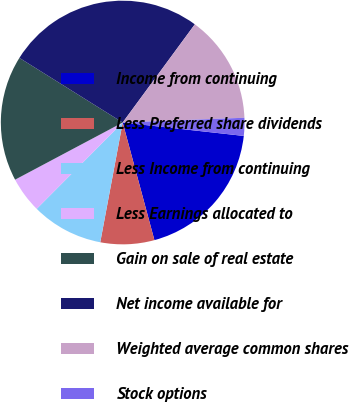Convert chart. <chart><loc_0><loc_0><loc_500><loc_500><pie_chart><fcel>Income from continuing<fcel>Less Preferred share dividends<fcel>Less Income from continuing<fcel>Less Earnings allocated to<fcel>Gain on sale of real estate<fcel>Net income available for<fcel>Weighted average common shares<fcel>Stock options<nl><fcel>19.05%<fcel>7.14%<fcel>9.52%<fcel>4.76%<fcel>16.67%<fcel>26.19%<fcel>14.29%<fcel>2.38%<nl></chart> 